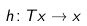Convert formula to latex. <formula><loc_0><loc_0><loc_500><loc_500>h \colon T x \to x</formula> 